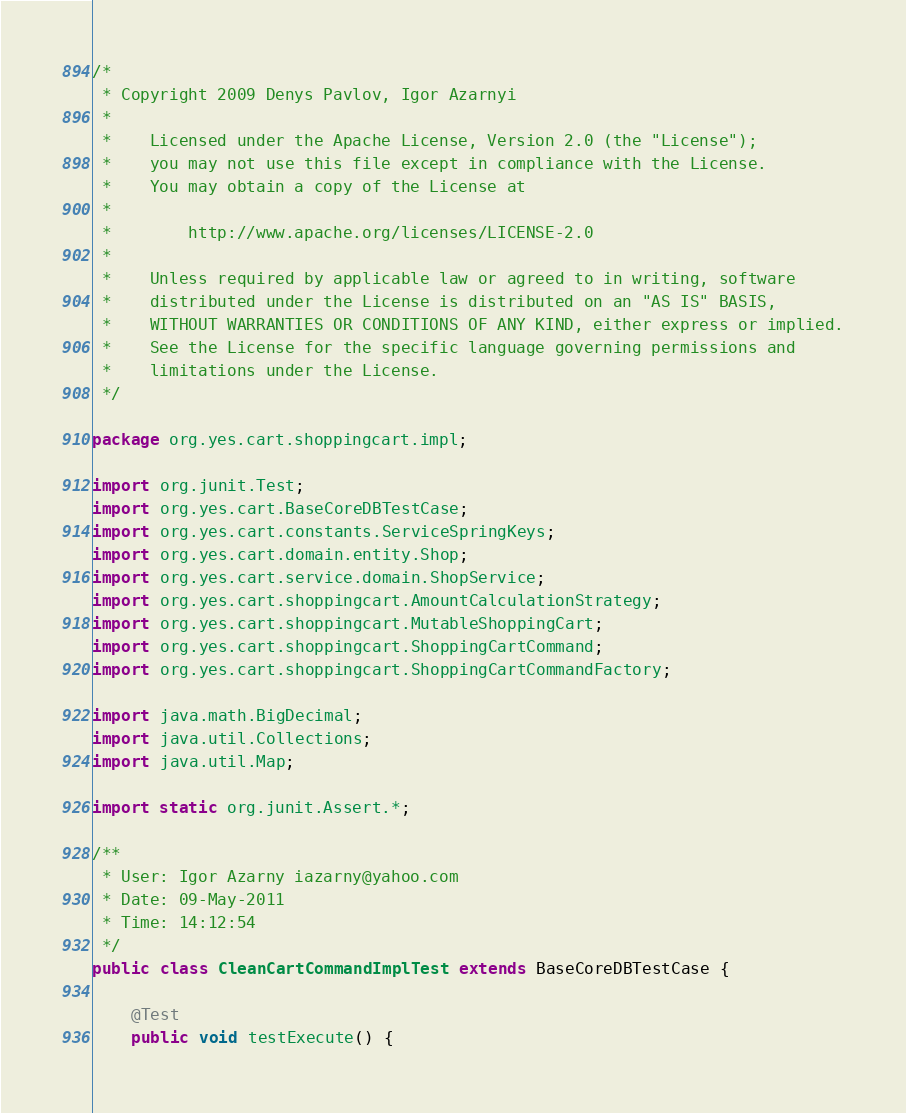<code> <loc_0><loc_0><loc_500><loc_500><_Java_>/*
 * Copyright 2009 Denys Pavlov, Igor Azarnyi
 *
 *    Licensed under the Apache License, Version 2.0 (the "License");
 *    you may not use this file except in compliance with the License.
 *    You may obtain a copy of the License at
 *
 *        http://www.apache.org/licenses/LICENSE-2.0
 *
 *    Unless required by applicable law or agreed to in writing, software
 *    distributed under the License is distributed on an "AS IS" BASIS,
 *    WITHOUT WARRANTIES OR CONDITIONS OF ANY KIND, either express or implied.
 *    See the License for the specific language governing permissions and
 *    limitations under the License.
 */

package org.yes.cart.shoppingcart.impl;

import org.junit.Test;
import org.yes.cart.BaseCoreDBTestCase;
import org.yes.cart.constants.ServiceSpringKeys;
import org.yes.cart.domain.entity.Shop;
import org.yes.cart.service.domain.ShopService;
import org.yes.cart.shoppingcart.AmountCalculationStrategy;
import org.yes.cart.shoppingcart.MutableShoppingCart;
import org.yes.cart.shoppingcart.ShoppingCartCommand;
import org.yes.cart.shoppingcart.ShoppingCartCommandFactory;

import java.math.BigDecimal;
import java.util.Collections;
import java.util.Map;

import static org.junit.Assert.*;

/**
 * User: Igor Azarny iazarny@yahoo.com
 * Date: 09-May-2011
 * Time: 14:12:54
 */
public class CleanCartCommandImplTest extends BaseCoreDBTestCase {

    @Test
    public void testExecute() {
</code> 